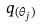Convert formula to latex. <formula><loc_0><loc_0><loc_500><loc_500>q _ { ( \theta _ { j } ) }</formula> 